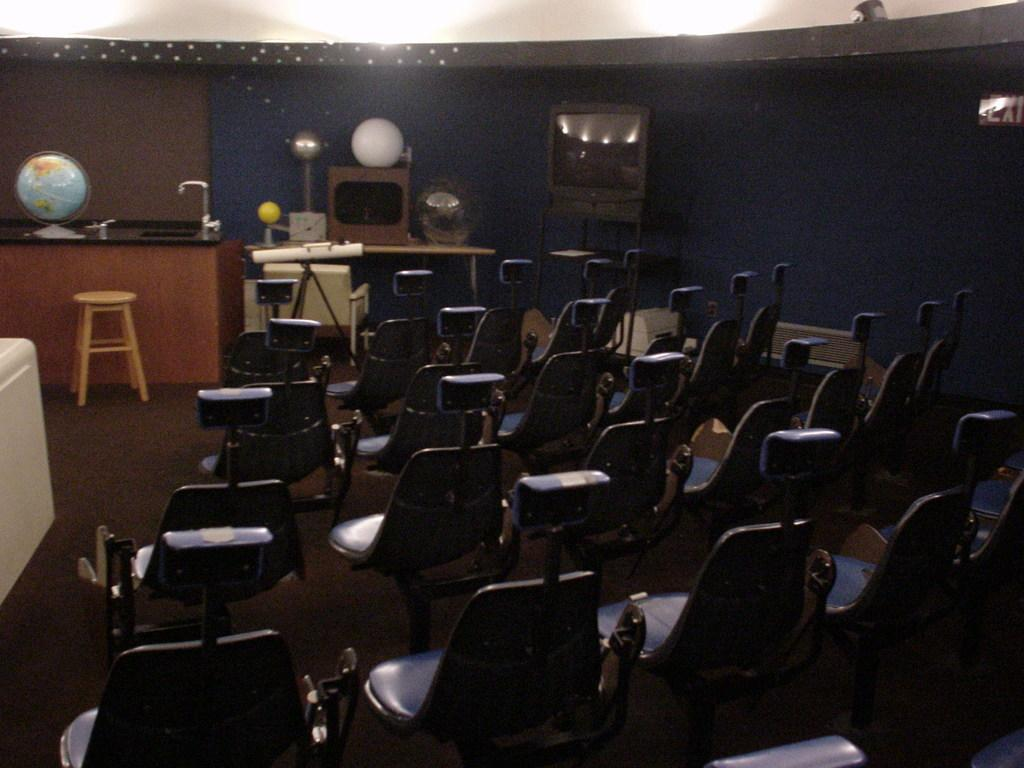What type of furniture is present in the image? There are chairs and a stool in the image. What type of educational or decorative items can be seen in the image? There are globes in the image. What type of objects are elevated on stands in the image? There are objects on stands in the image. What type of illumination is present in the image? There are lights in the image. What type of architectural feature is visible in the image? There is a wall in the image. Can you tell me how many cows are swimming in the image? There are no cows or swimming activities present in the image. What type of toothpaste is being used in the image? There is no toothpaste or toothpaste-related activity present in the image. 